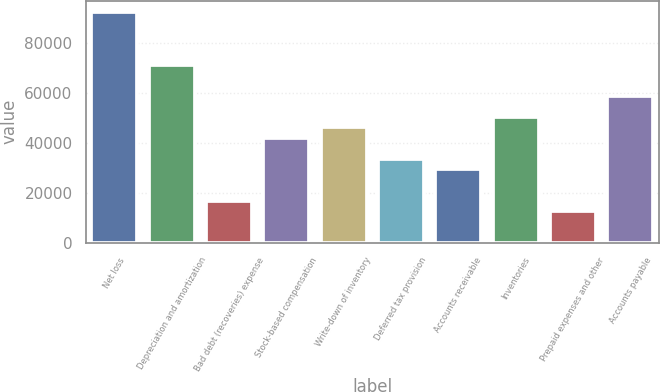Convert chart to OTSL. <chart><loc_0><loc_0><loc_500><loc_500><bar_chart><fcel>Net loss<fcel>Depreciation and amortization<fcel>Bad debt (recoveries) expense<fcel>Stock-based compensation<fcel>Write-down of inventory<fcel>Deferred tax provision<fcel>Accounts receivable<fcel>Inventories<fcel>Prepaid expenses and other<fcel>Accounts payable<nl><fcel>92364.4<fcel>71385.9<fcel>16841.8<fcel>42016<fcel>46211.7<fcel>33624.6<fcel>29428.9<fcel>50407.4<fcel>12646.1<fcel>58798.8<nl></chart> 